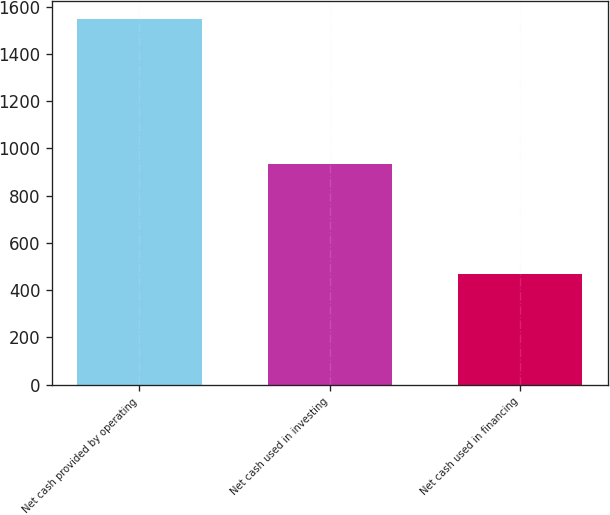<chart> <loc_0><loc_0><loc_500><loc_500><bar_chart><fcel>Net cash provided by operating<fcel>Net cash used in investing<fcel>Net cash used in financing<nl><fcel>1548.2<fcel>933.9<fcel>468.6<nl></chart> 